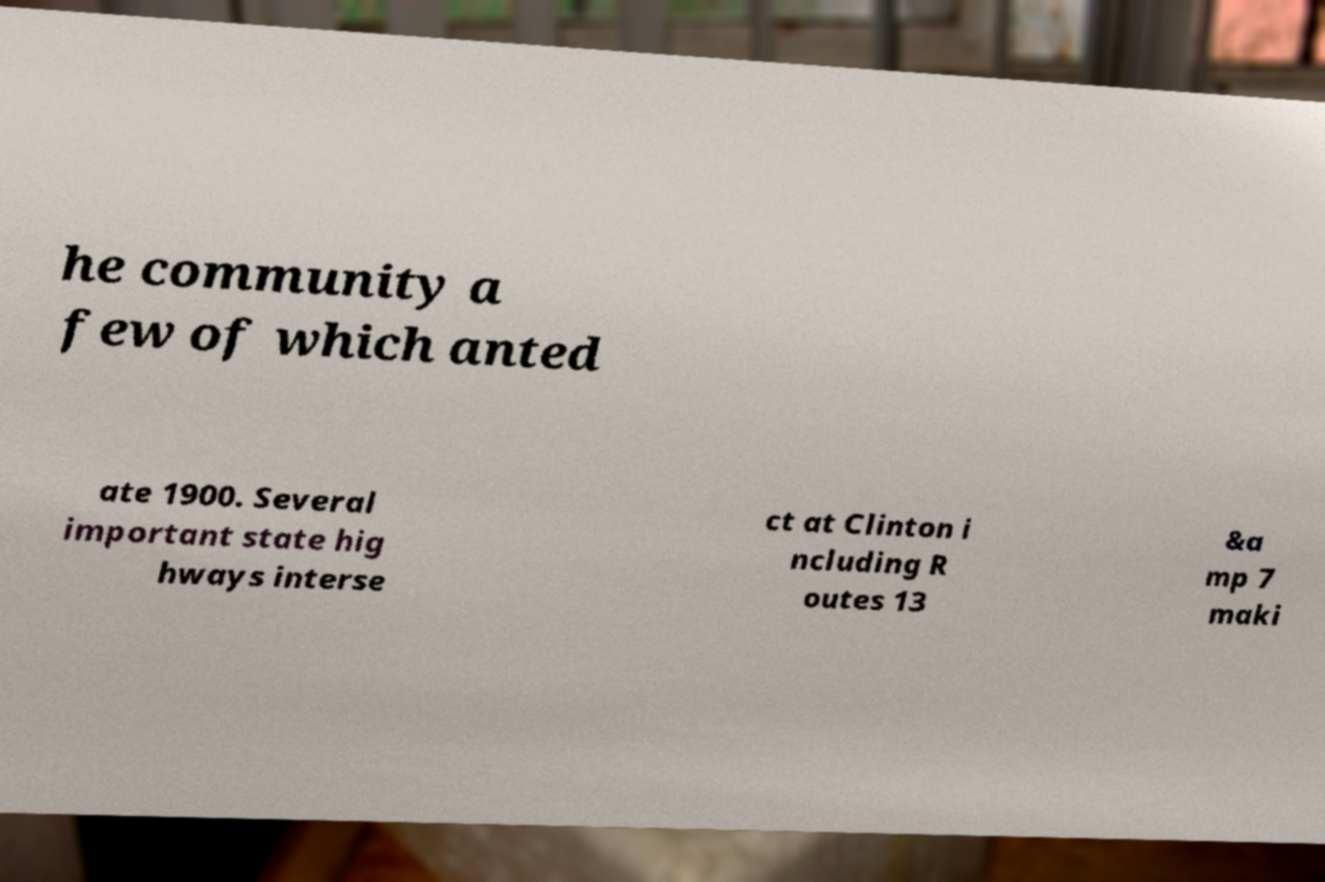Can you accurately transcribe the text from the provided image for me? he community a few of which anted ate 1900. Several important state hig hways interse ct at Clinton i ncluding R outes 13 &a mp 7 maki 